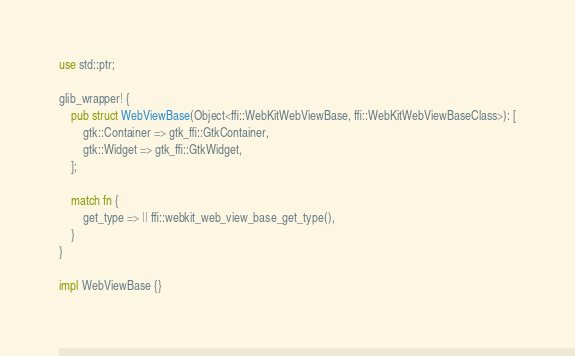Convert code to text. <code><loc_0><loc_0><loc_500><loc_500><_Rust_>use std::ptr;

glib_wrapper! {
    pub struct WebViewBase(Object<ffi::WebKitWebViewBase, ffi::WebKitWebViewBaseClass>): [
        gtk::Container => gtk_ffi::GtkContainer,
        gtk::Widget => gtk_ffi::GtkWidget,
    ];

    match fn {
        get_type => || ffi::webkit_web_view_base_get_type(),
    }
}

impl WebViewBase {}
</code> 